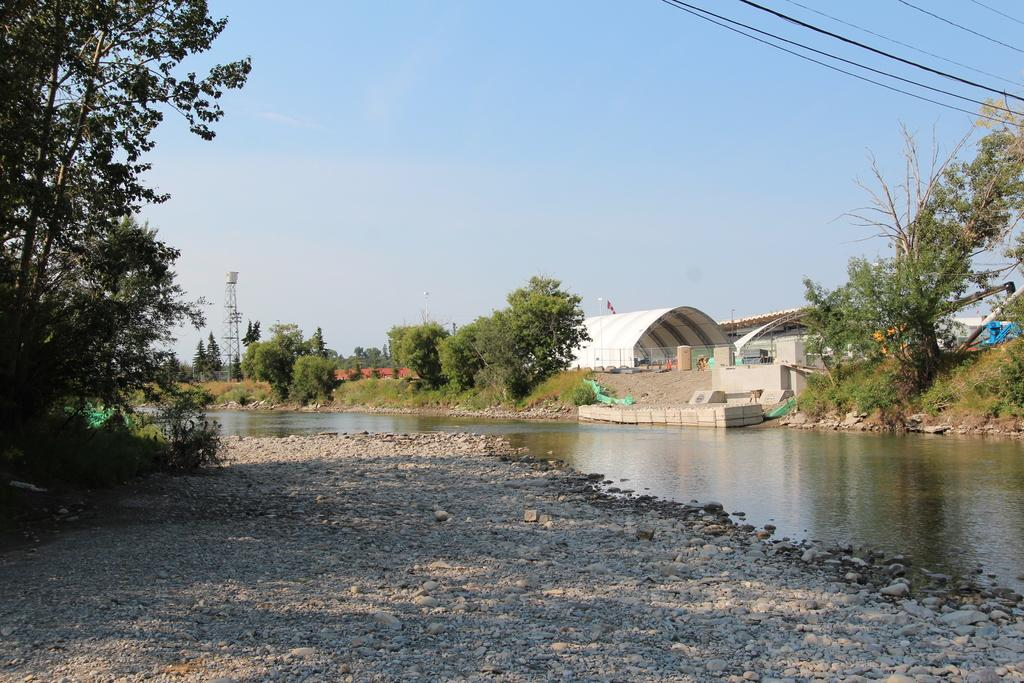What type of vegetation can be seen in the image? There are trees in the image. What type of structure is present in the image? There is a tunnel in the image. What is at the bottom of the image? There are stones at the bottom of the image. What natural element is visible in the image? There is water visible in the image. What can be seen in the background of the image? There is a tower, the sky, and wires visible in the background of the image. What type of creature is seen playing with the fire in the image? There is no fire or creature present in the image. How many people are visible in the image? The provided facts do not mention any people in the image, so we cannot determine the number of people present. 